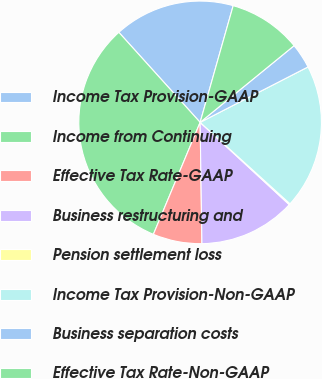Convert chart to OTSL. <chart><loc_0><loc_0><loc_500><loc_500><pie_chart><fcel>Income Tax Provision-GAAP<fcel>Income from Continuing<fcel>Effective Tax Rate-GAAP<fcel>Business restructuring and<fcel>Pension settlement loss<fcel>Income Tax Provision-Non-GAAP<fcel>Business separation costs<fcel>Effective Tax Rate-Non-GAAP<nl><fcel>16.08%<fcel>32.02%<fcel>6.53%<fcel>12.9%<fcel>0.15%<fcel>19.27%<fcel>3.34%<fcel>9.71%<nl></chart> 